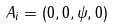<formula> <loc_0><loc_0><loc_500><loc_500>A _ { i } = ( 0 , 0 , \psi , 0 )</formula> 